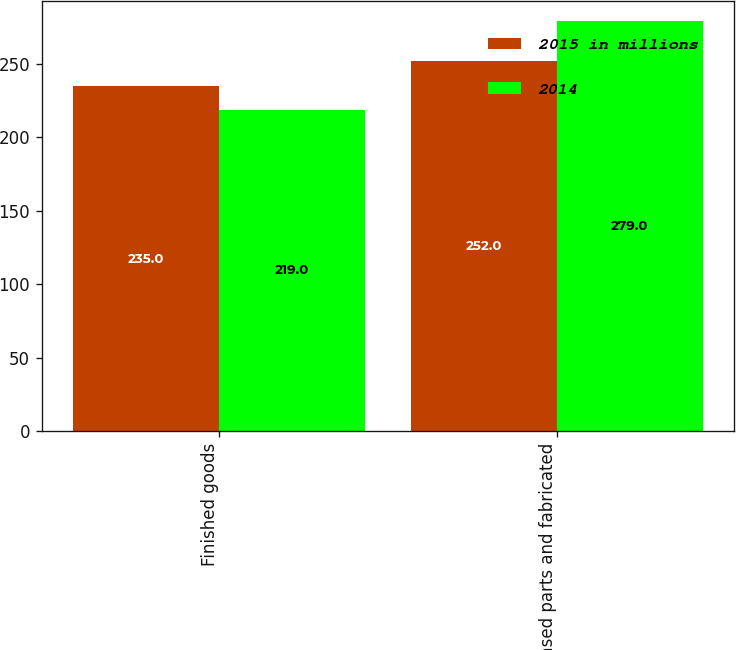<chart> <loc_0><loc_0><loc_500><loc_500><stacked_bar_chart><ecel><fcel>Finished goods<fcel>Purchased parts and fabricated<nl><fcel>2015 in millions<fcel>235<fcel>252<nl><fcel>2014<fcel>219<fcel>279<nl></chart> 